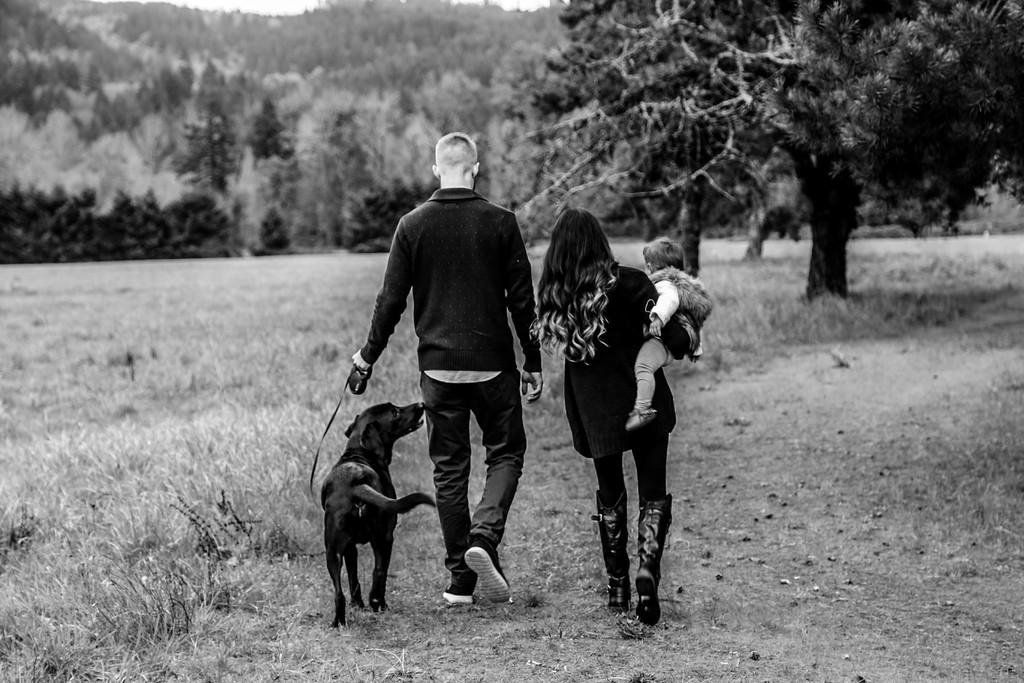What are the two persons in the image doing? The two persons in the image are walking. What is the man holding in the image? The man is holding a dog. What is the woman holding in the image? The woman is holding a baby. What can be seen in the background of the image? There are trees and grass in the background of the image. What type of wax can be seen melting in the image? There is no wax present in the image. How many beds are visible in the image? There are no beds visible in the image. 